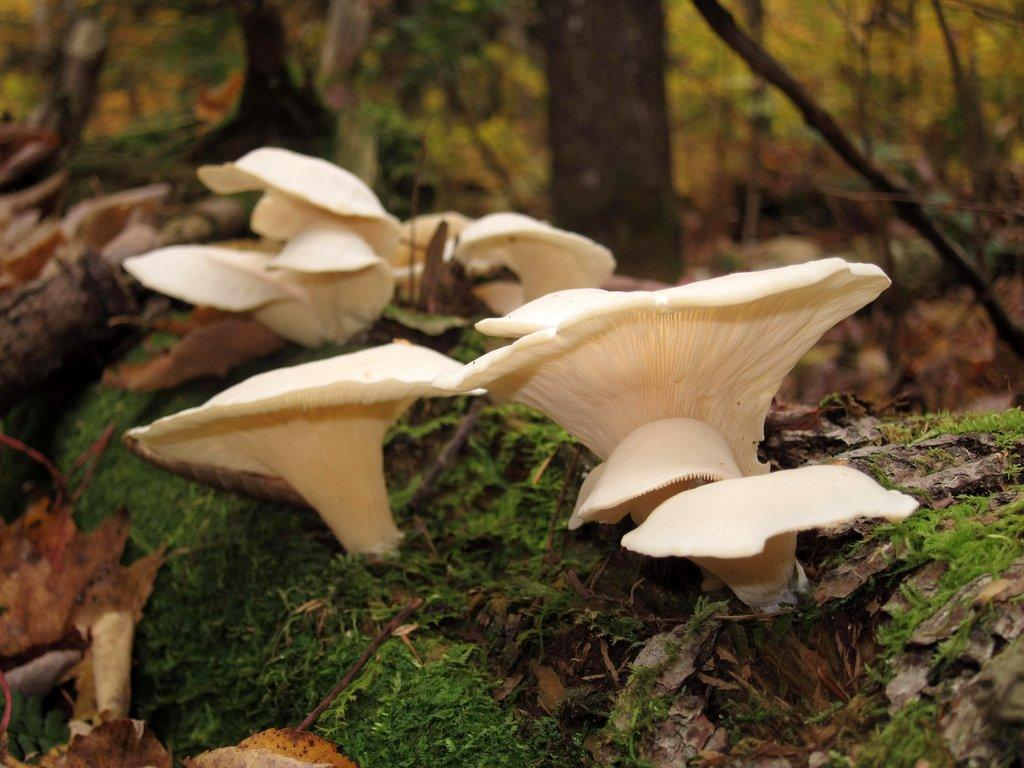What type of fungi can be seen in the image? There are mushrooms in the image. What color are the mushrooms? The mushrooms are cream-colored. What type of vegetation is visible in the image? There is grass visible in the image. What other natural elements can be seen in the image? There are trees in the image. What is the purpose of the pan in the image? There is no pan present in the image. 